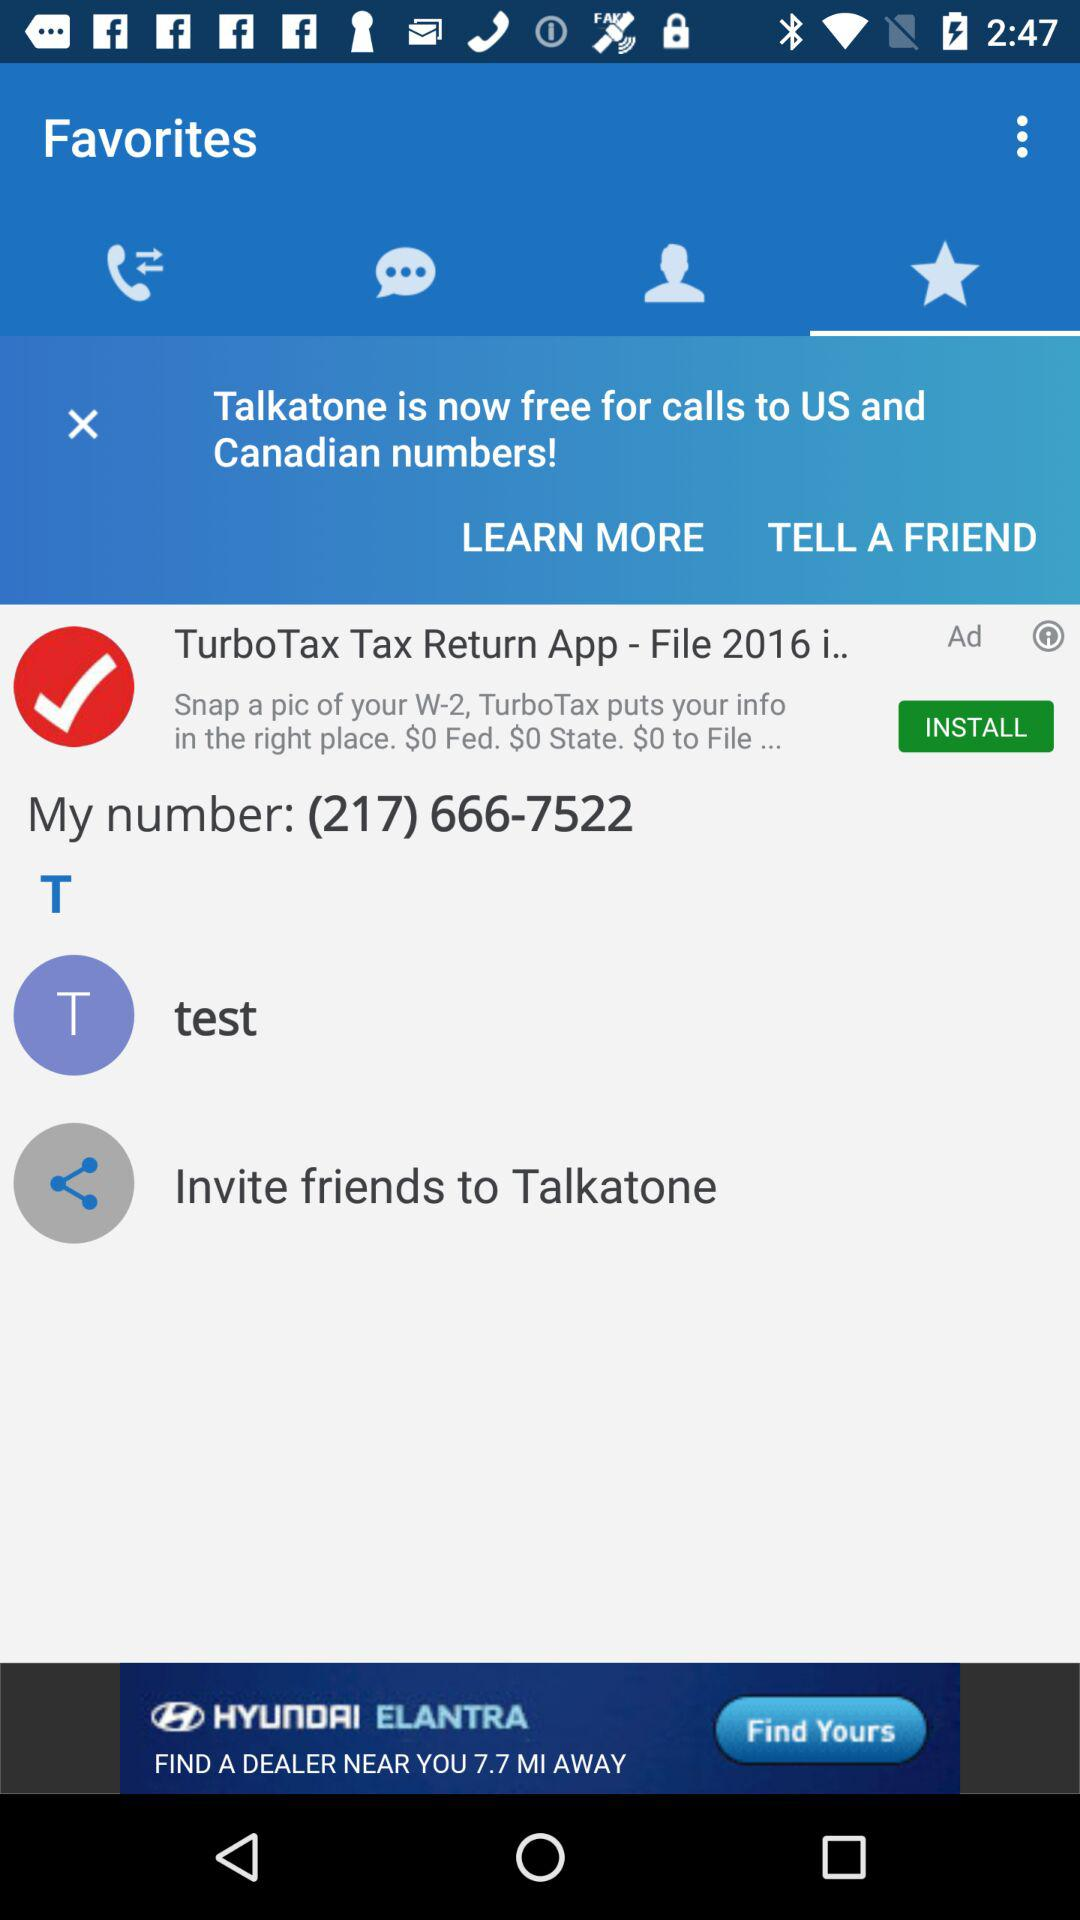Which applications are available for inviting friends to "Talkatone"?
When the provided information is insufficient, respond with <no answer>. <no answer> 